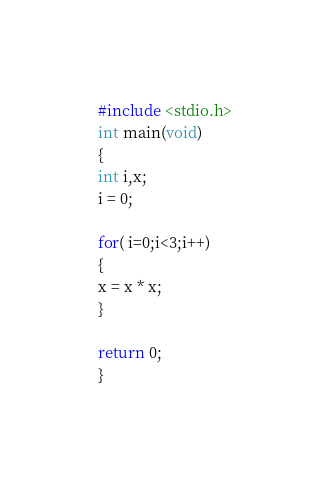Convert code to text. <code><loc_0><loc_0><loc_500><loc_500><_C_>#include <stdio.h>
int main(void)
{
int i,x;
i = 0;

for( i=0;i<3;i++)
{
x = x * x;
}

return 0;
}</code> 